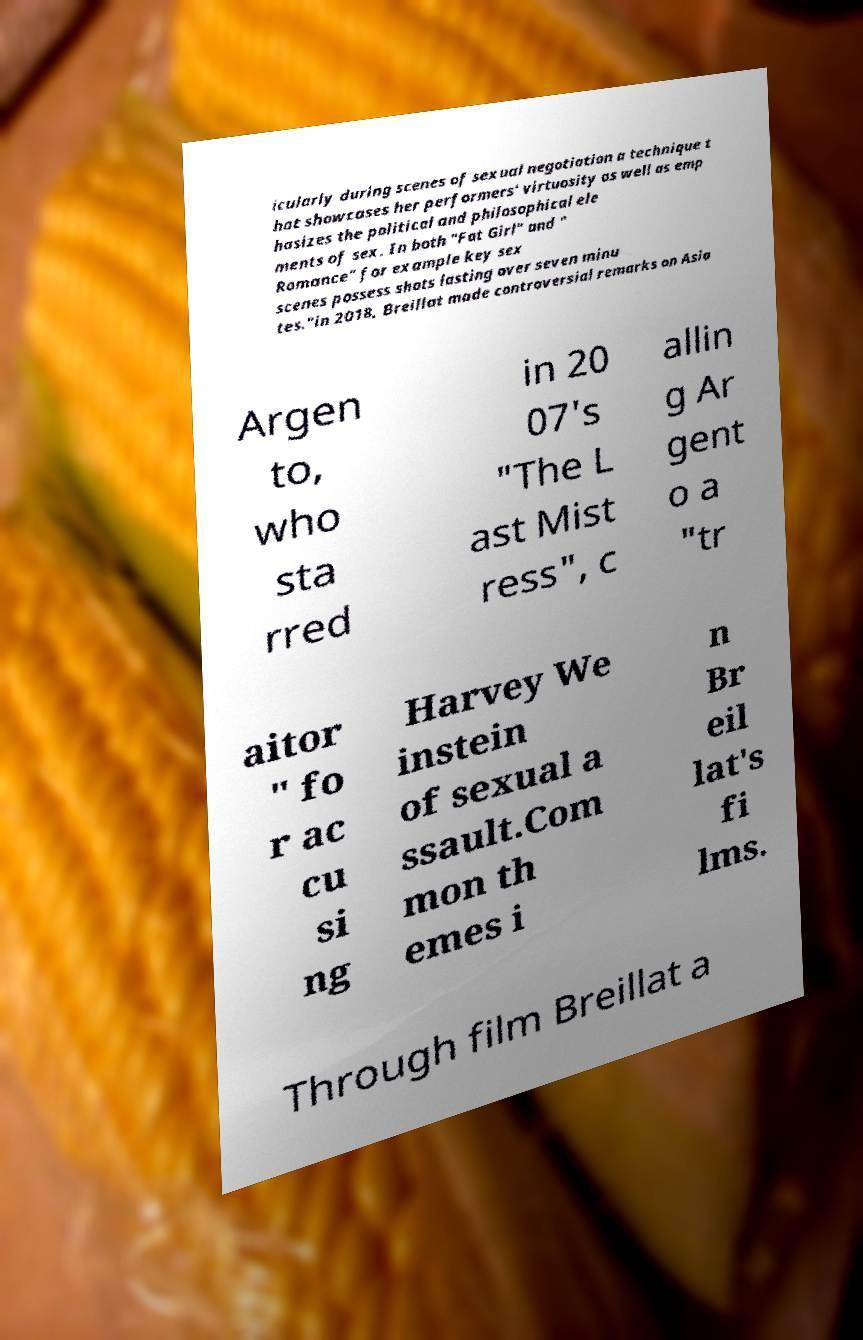Please identify and transcribe the text found in this image. icularly during scenes of sexual negotiation a technique t hat showcases her performers' virtuosity as well as emp hasizes the political and philosophical ele ments of sex. In both "Fat Girl" and " Romance" for example key sex scenes possess shots lasting over seven minu tes."in 2018, Breillat made controversial remarks on Asia Argen to, who sta rred in 20 07's "The L ast Mist ress", c allin g Ar gent o a "tr aitor " fo r ac cu si ng Harvey We instein of sexual a ssault.Com mon th emes i n Br eil lat's fi lms. Through film Breillat a 